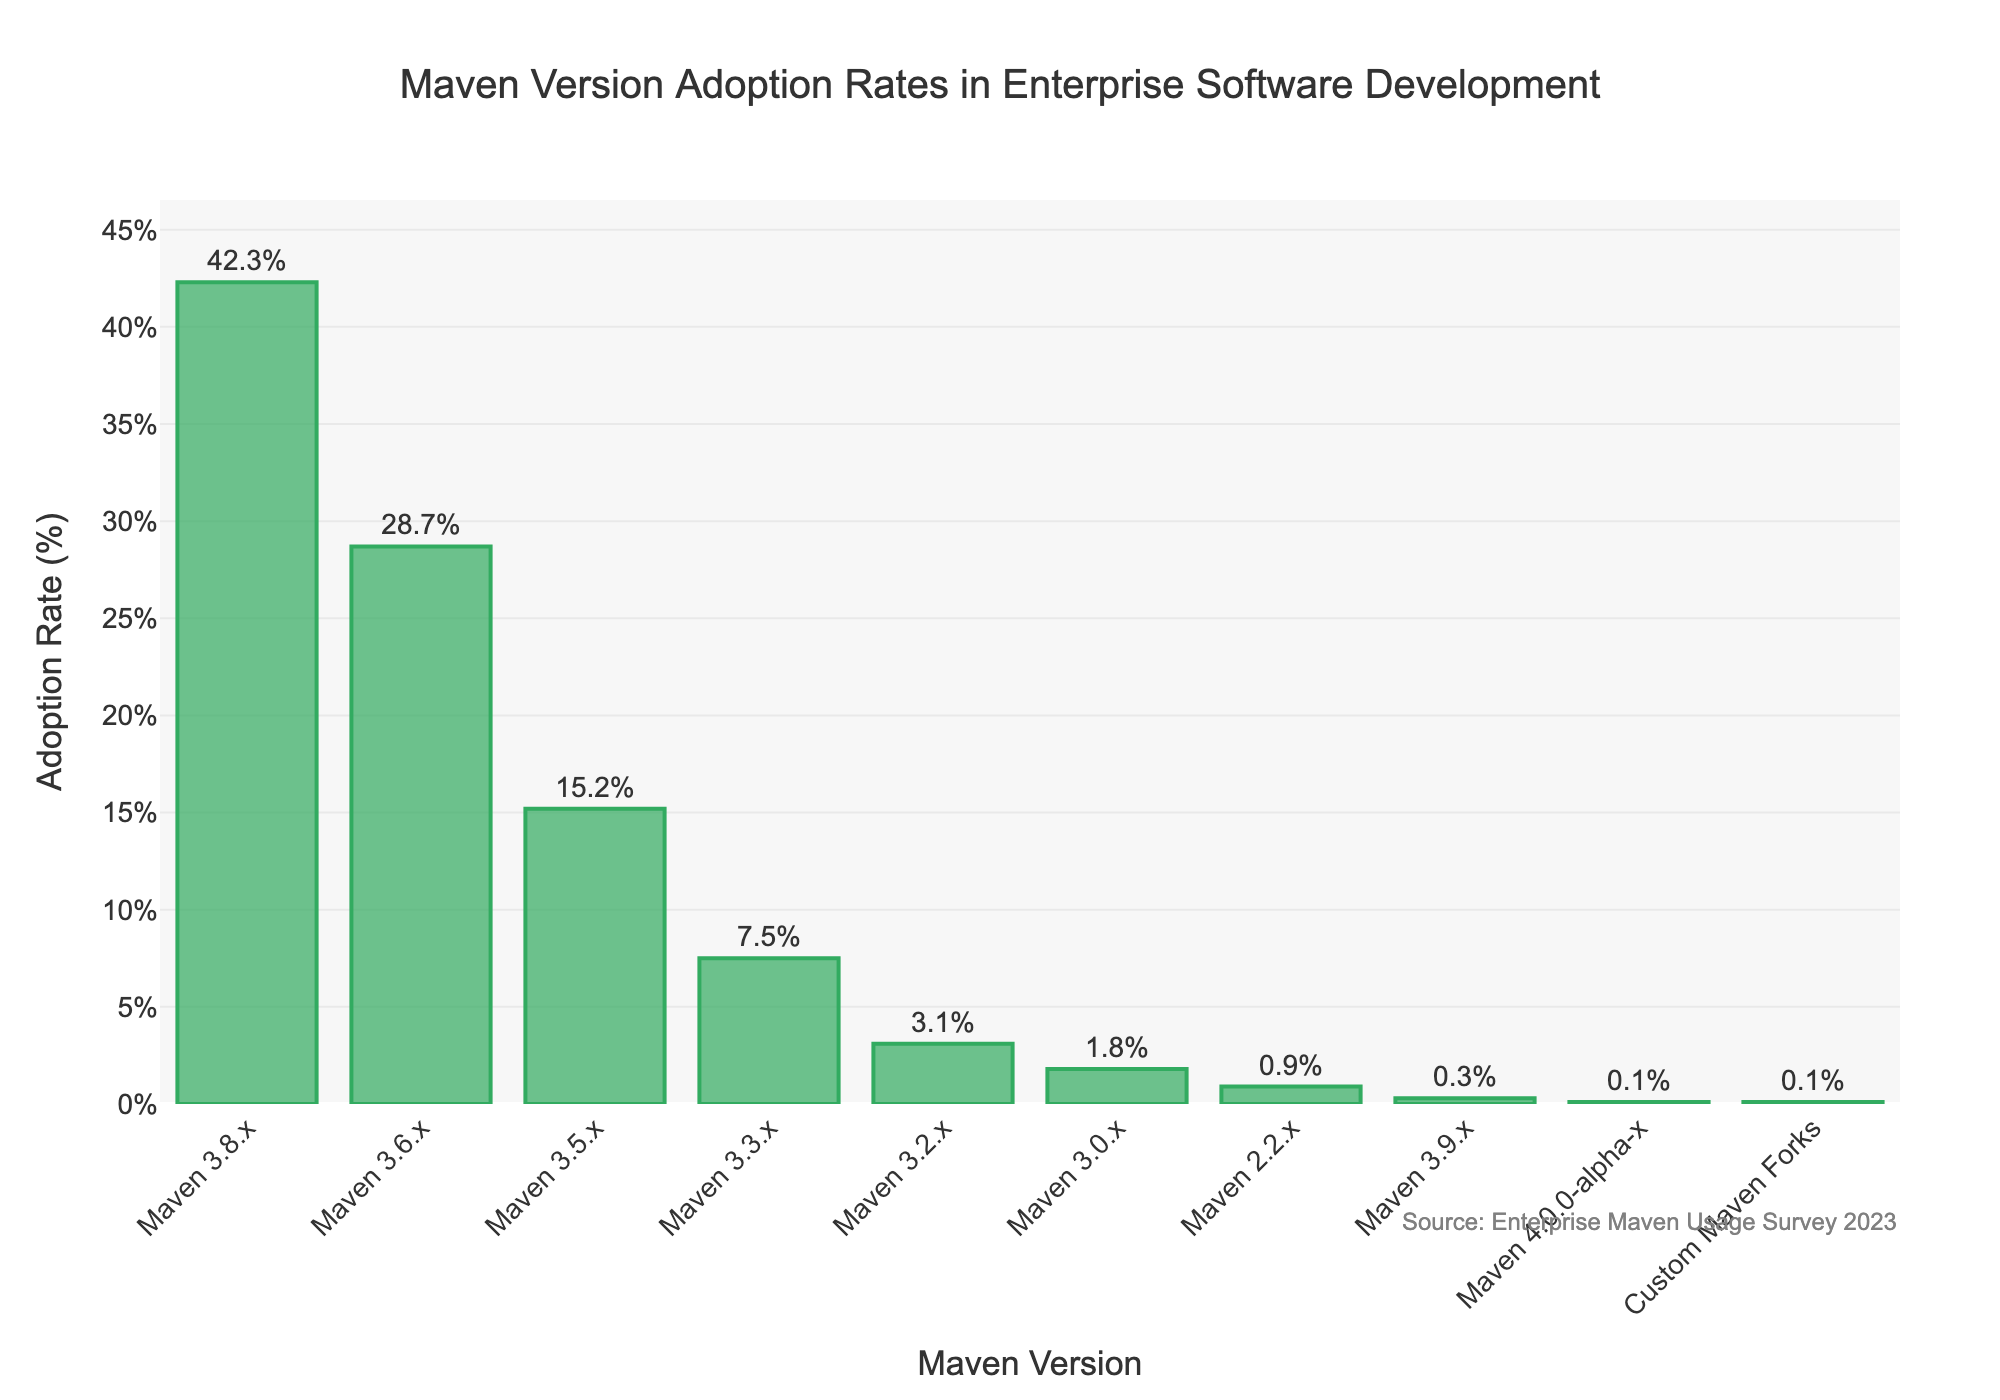Which Maven version has the highest adoption rate? By observing the height of the bars, the bar for Maven 3.8.x is the tallest, indicating it has the highest adoption rate.
Answer: Maven 3.8.x What's the total adoption rate for Maven versions 3.3.x and older? Sum the adoption rates for Maven 3.3.x, 3.2.x, 3.0.x, 2.2.x, 3.9.x, and 4.0.0-alpha-x: 7.5 + 3.1 + 1.8 + 0.9 + 0.3 + 0.1 = 13.7%
Answer: 13.7% Which Maven version has the lowest adoption rate? The shortest bar represents the version with the lowest rate, which is Maven 4.0.0-alpha-x, tied with Custom Maven Forks, each at 0.1%.
Answer: Maven 4.0.0-alpha-x and Custom Maven Forks What's the combined adoption rate of Maven 3.6.x and 3.5.x? Add the adoption rates of Maven 3.6.x and 3.5.x: 28.7 + 15.2 = 43.9%
Answer: 43.9% Is the adoption rate of Maven 3.8.x more than double that of Maven 3.6.x? Compare twice the adoption rate of Maven 3.6.x with Maven 3.8.x: 28.7 * 2 = 57.4, which is more than 42.3, so it's not more than double.
Answer: No What is the difference in adoption rate between Maven 3.8.x and Maven 3.6.x? Subtract the adoption rate of Maven 3.6.x from Maven 3.8.x: 42.3 - 28.7 = 13.6%
Answer: 13.6% What's the average adoption rate of the versions starting with "3"? Sum the adoption rates of Maven 3.8.x, 3.6.x, 3.5.x, 3.3.x, 3.2.x, 3.0.x, and 3.9.x, then divide by 7: (42.3 + 28.7 + 15.2 + 7.5 + 3.1 + 1.8 + 0.3) / 7 = 14.13%
Answer: 14.13% Which Maven version has a mid-range adoption rate? By arranging the adoption rates in ascending order, the mid-range value is the fourth: 0.1, 0.9, 1.8, 3.1, 7.5, 15.2, 28.7, 42.3. So, Maven 3.2.x with 3.1% is at mid-range.
Answer: Maven 3.2.x 